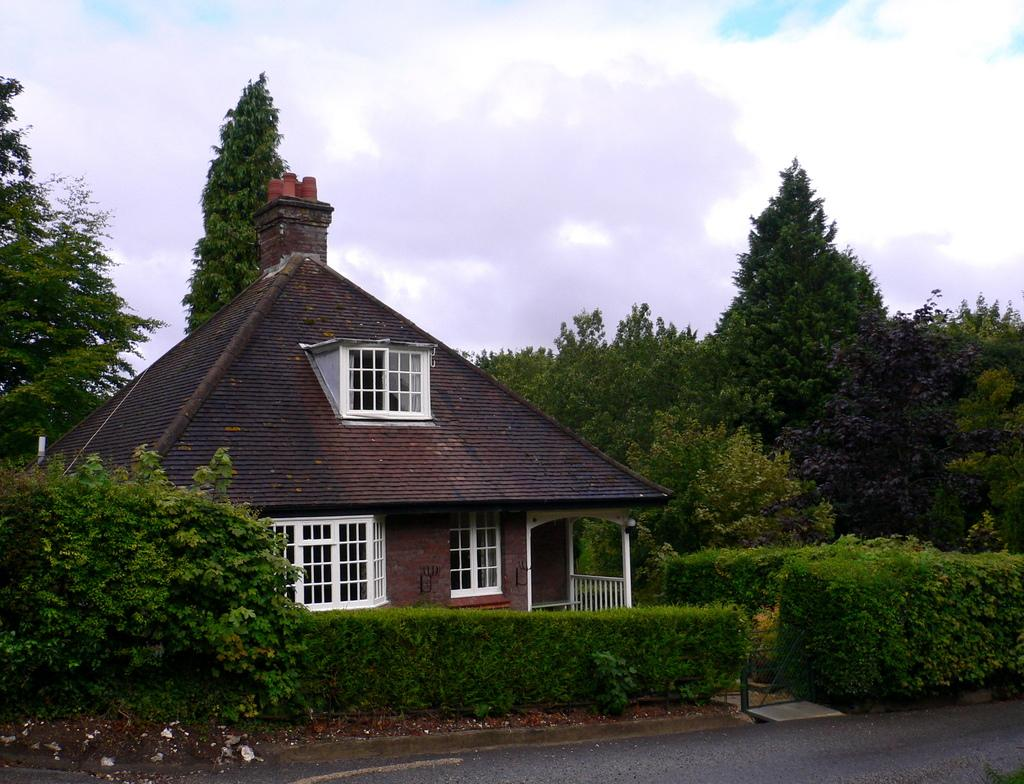What type of structure is in the image? There is a house in the image. What features can be seen on the house? The house has windows. What is visible around the house? There are trees and plants around the house. How would you describe the sky in the image? The sky is cloudy. Where is the box located in the image? There is no box present in the image. Can you see the minister walking on the sidewalk in the image? There is no sidewalk or minister present in the image. 